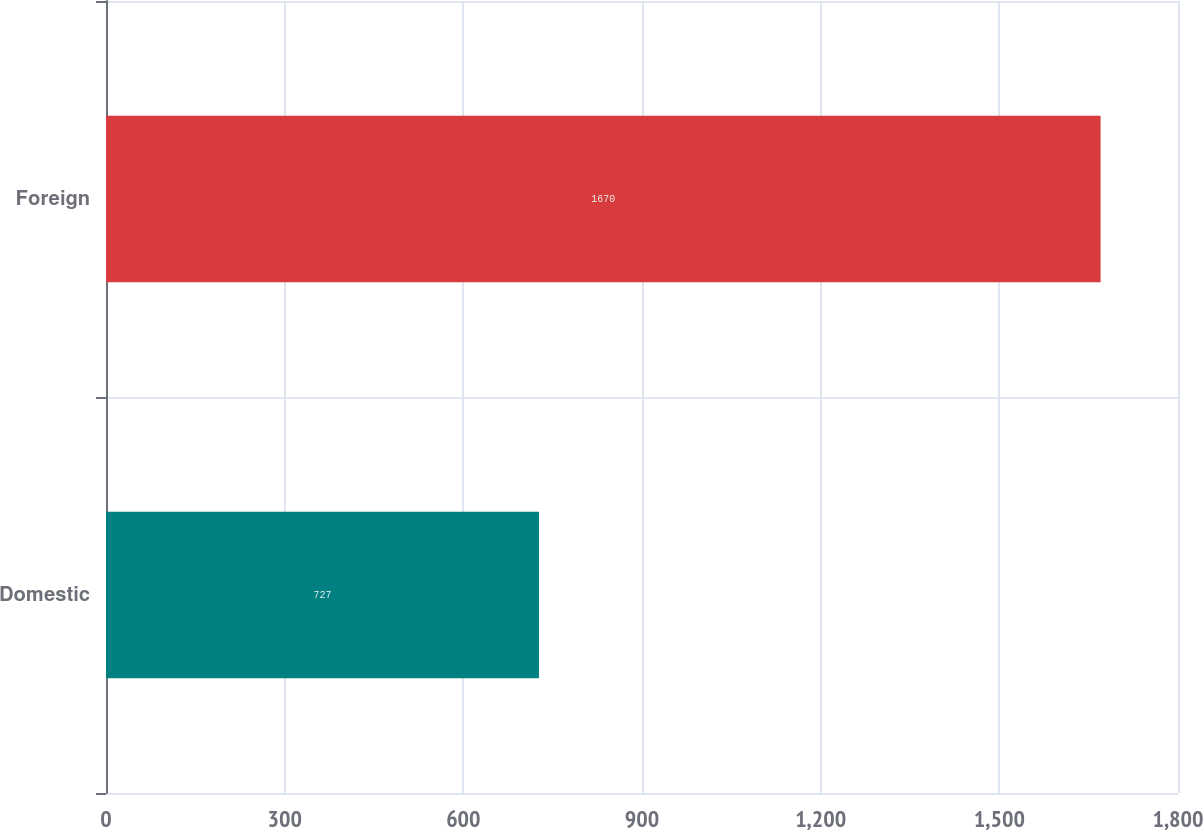Convert chart to OTSL. <chart><loc_0><loc_0><loc_500><loc_500><bar_chart><fcel>Domestic<fcel>Foreign<nl><fcel>727<fcel>1670<nl></chart> 